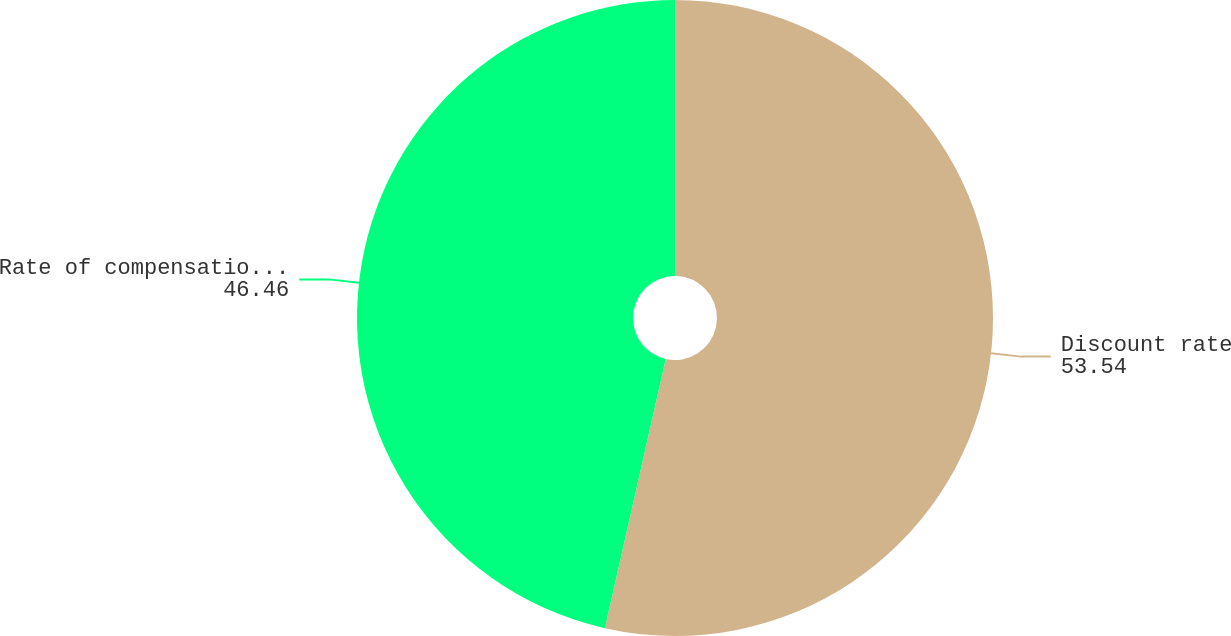Convert chart to OTSL. <chart><loc_0><loc_0><loc_500><loc_500><pie_chart><fcel>Discount rate<fcel>Rate of compensation increase<nl><fcel>53.54%<fcel>46.46%<nl></chart> 